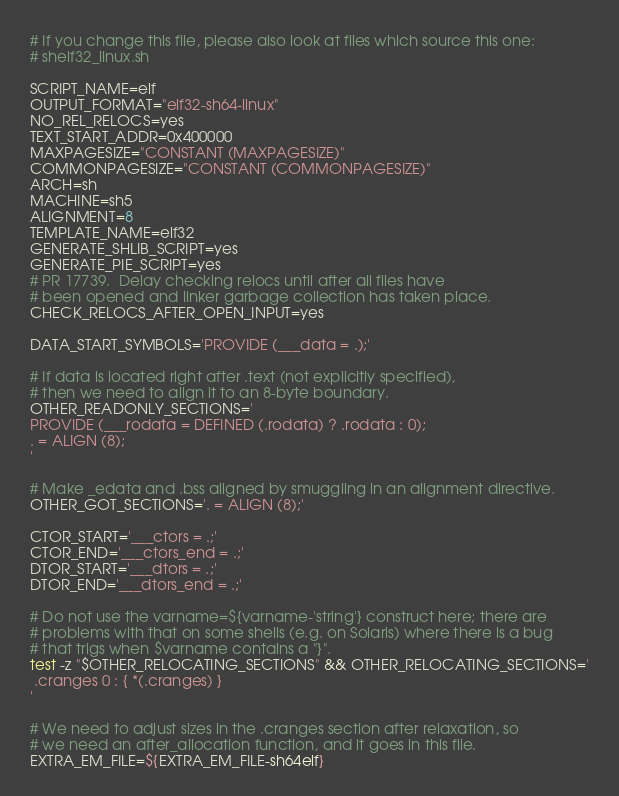Convert code to text. <code><loc_0><loc_0><loc_500><loc_500><_Bash_># If you change this file, please also look at files which source this one:
# shelf32_linux.sh

SCRIPT_NAME=elf
OUTPUT_FORMAT="elf32-sh64-linux"
NO_REL_RELOCS=yes
TEXT_START_ADDR=0x400000
MAXPAGESIZE="CONSTANT (MAXPAGESIZE)"
COMMONPAGESIZE="CONSTANT (COMMONPAGESIZE)"
ARCH=sh
MACHINE=sh5
ALIGNMENT=8
TEMPLATE_NAME=elf32
GENERATE_SHLIB_SCRIPT=yes
GENERATE_PIE_SCRIPT=yes
# PR 17739.  Delay checking relocs until after all files have
# been opened and linker garbage collection has taken place.
CHECK_RELOCS_AFTER_OPEN_INPUT=yes

DATA_START_SYMBOLS='PROVIDE (___data = .);'

# If data is located right after .text (not explicitly specified),
# then we need to align it to an 8-byte boundary.
OTHER_READONLY_SECTIONS='
PROVIDE (___rodata = DEFINED (.rodata) ? .rodata : 0);
. = ALIGN (8);
'

# Make _edata and .bss aligned by smuggling in an alignment directive.
OTHER_GOT_SECTIONS='. = ALIGN (8);'

CTOR_START='___ctors = .;'
CTOR_END='___ctors_end = .;'
DTOR_START='___dtors = .;'
DTOR_END='___dtors_end = .;'

# Do not use the varname=${varname-'string'} construct here; there are
# problems with that on some shells (e.g. on Solaris) where there is a bug
# that trigs when $varname contains a "}".
test -z "$OTHER_RELOCATING_SECTIONS" && OTHER_RELOCATING_SECTIONS='
 .cranges 0 : { *(.cranges) }
'

# We need to adjust sizes in the .cranges section after relaxation, so
# we need an after_allocation function, and it goes in this file.
EXTRA_EM_FILE=${EXTRA_EM_FILE-sh64elf}
</code> 